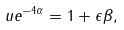<formula> <loc_0><loc_0><loc_500><loc_500>\ u e ^ { - 4 \alpha } = 1 + \epsilon \beta ,</formula> 